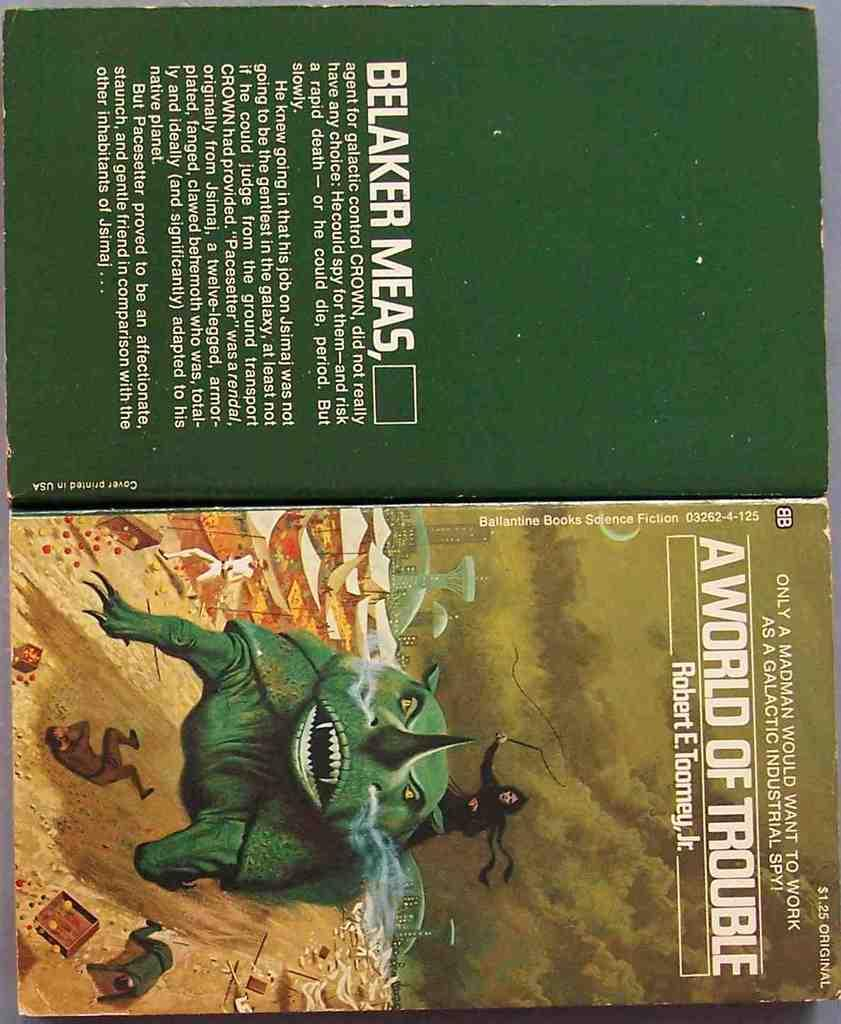Provide a one-sentence caption for the provided image. The book A World of Trouble has a green creature on the cover. 